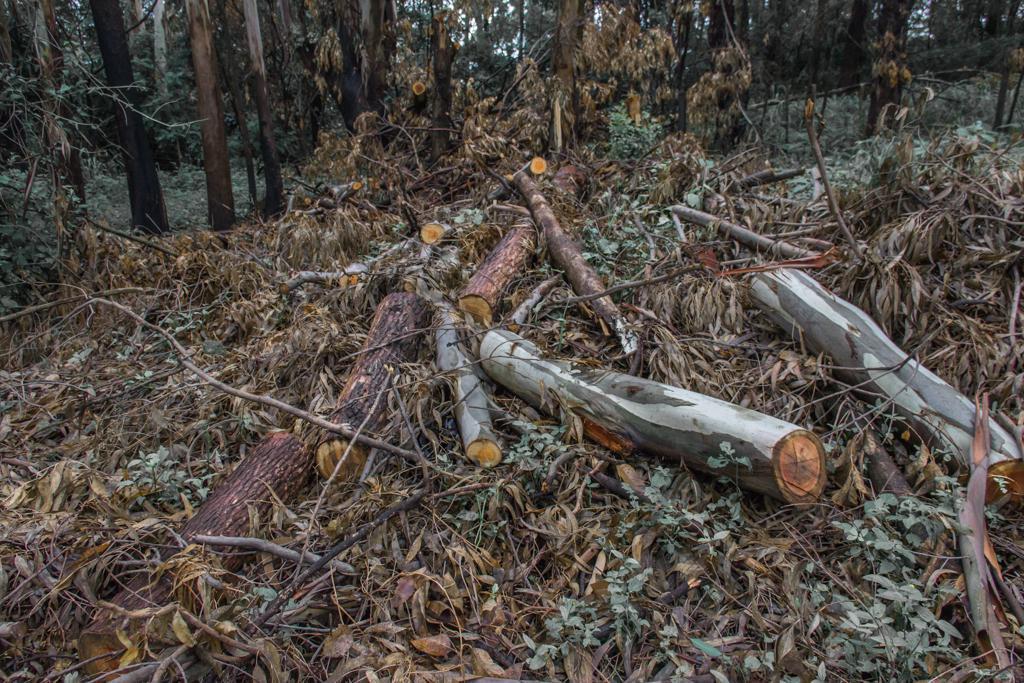In one or two sentences, can you explain what this image depicts? In this image I can see few trees, dry leaves and few wooden logs. 